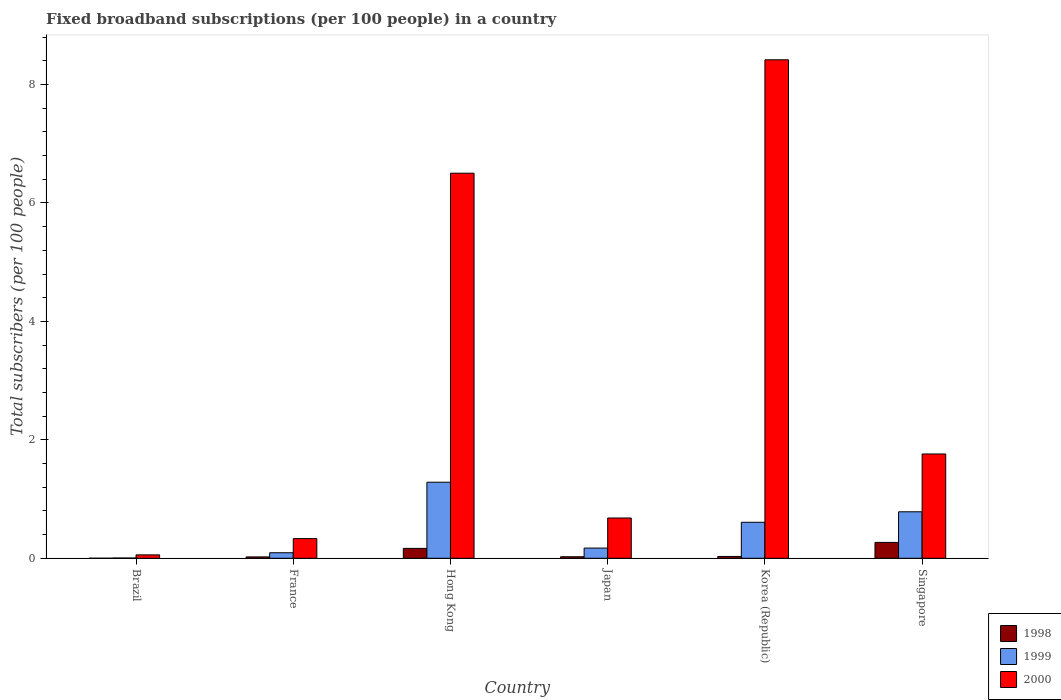Are the number of bars per tick equal to the number of legend labels?
Ensure brevity in your answer.  Yes. Are the number of bars on each tick of the X-axis equal?
Make the answer very short. Yes. What is the label of the 2nd group of bars from the left?
Keep it short and to the point. France. What is the number of broadband subscriptions in 1999 in Korea (Republic)?
Your answer should be very brief. 0.61. Across all countries, what is the maximum number of broadband subscriptions in 1999?
Keep it short and to the point. 1.28. Across all countries, what is the minimum number of broadband subscriptions in 1999?
Offer a terse response. 0. In which country was the number of broadband subscriptions in 1999 maximum?
Offer a very short reply. Hong Kong. In which country was the number of broadband subscriptions in 2000 minimum?
Provide a succinct answer. Brazil. What is the total number of broadband subscriptions in 1999 in the graph?
Your answer should be compact. 2.95. What is the difference between the number of broadband subscriptions in 2000 in Brazil and that in Korea (Republic)?
Keep it short and to the point. -8.36. What is the difference between the number of broadband subscriptions in 1999 in France and the number of broadband subscriptions in 2000 in Brazil?
Make the answer very short. 0.04. What is the average number of broadband subscriptions in 1999 per country?
Your answer should be very brief. 0.49. What is the difference between the number of broadband subscriptions of/in 1999 and number of broadband subscriptions of/in 2000 in France?
Your answer should be compact. -0.24. In how many countries, is the number of broadband subscriptions in 1999 greater than 3.6?
Give a very brief answer. 0. What is the ratio of the number of broadband subscriptions in 1998 in Hong Kong to that in Korea (Republic)?
Your answer should be very brief. 5.42. What is the difference between the highest and the second highest number of broadband subscriptions in 1998?
Give a very brief answer. 0.1. What is the difference between the highest and the lowest number of broadband subscriptions in 1998?
Your answer should be very brief. 0.27. Is the sum of the number of broadband subscriptions in 1999 in Hong Kong and Japan greater than the maximum number of broadband subscriptions in 1998 across all countries?
Keep it short and to the point. Yes. How many bars are there?
Ensure brevity in your answer.  18. Are all the bars in the graph horizontal?
Give a very brief answer. No. What is the difference between two consecutive major ticks on the Y-axis?
Keep it short and to the point. 2. Are the values on the major ticks of Y-axis written in scientific E-notation?
Keep it short and to the point. No. What is the title of the graph?
Provide a succinct answer. Fixed broadband subscriptions (per 100 people) in a country. Does "2003" appear as one of the legend labels in the graph?
Provide a succinct answer. No. What is the label or title of the X-axis?
Keep it short and to the point. Country. What is the label or title of the Y-axis?
Ensure brevity in your answer.  Total subscribers (per 100 people). What is the Total subscribers (per 100 people) of 1998 in Brazil?
Your answer should be compact. 0. What is the Total subscribers (per 100 people) of 1999 in Brazil?
Your answer should be very brief. 0. What is the Total subscribers (per 100 people) in 2000 in Brazil?
Ensure brevity in your answer.  0.06. What is the Total subscribers (per 100 people) in 1998 in France?
Offer a terse response. 0.02. What is the Total subscribers (per 100 people) of 1999 in France?
Offer a very short reply. 0.09. What is the Total subscribers (per 100 people) of 2000 in France?
Your response must be concise. 0.33. What is the Total subscribers (per 100 people) of 1998 in Hong Kong?
Your answer should be compact. 0.17. What is the Total subscribers (per 100 people) in 1999 in Hong Kong?
Make the answer very short. 1.28. What is the Total subscribers (per 100 people) of 2000 in Hong Kong?
Your response must be concise. 6.5. What is the Total subscribers (per 100 people) of 1998 in Japan?
Your answer should be very brief. 0.03. What is the Total subscribers (per 100 people) of 1999 in Japan?
Your response must be concise. 0.17. What is the Total subscribers (per 100 people) of 2000 in Japan?
Make the answer very short. 0.68. What is the Total subscribers (per 100 people) of 1998 in Korea (Republic)?
Your answer should be compact. 0.03. What is the Total subscribers (per 100 people) of 1999 in Korea (Republic)?
Ensure brevity in your answer.  0.61. What is the Total subscribers (per 100 people) of 2000 in Korea (Republic)?
Your response must be concise. 8.42. What is the Total subscribers (per 100 people) of 1998 in Singapore?
Give a very brief answer. 0.27. What is the Total subscribers (per 100 people) in 1999 in Singapore?
Your answer should be very brief. 0.78. What is the Total subscribers (per 100 people) of 2000 in Singapore?
Provide a succinct answer. 1.76. Across all countries, what is the maximum Total subscribers (per 100 people) in 1998?
Provide a short and direct response. 0.27. Across all countries, what is the maximum Total subscribers (per 100 people) in 1999?
Your response must be concise. 1.28. Across all countries, what is the maximum Total subscribers (per 100 people) of 2000?
Offer a very short reply. 8.42. Across all countries, what is the minimum Total subscribers (per 100 people) of 1998?
Your answer should be compact. 0. Across all countries, what is the minimum Total subscribers (per 100 people) in 1999?
Ensure brevity in your answer.  0. Across all countries, what is the minimum Total subscribers (per 100 people) of 2000?
Provide a succinct answer. 0.06. What is the total Total subscribers (per 100 people) in 1998 in the graph?
Offer a terse response. 0.51. What is the total Total subscribers (per 100 people) in 1999 in the graph?
Provide a succinct answer. 2.95. What is the total Total subscribers (per 100 people) of 2000 in the graph?
Give a very brief answer. 17.75. What is the difference between the Total subscribers (per 100 people) in 1998 in Brazil and that in France?
Your answer should be compact. -0.02. What is the difference between the Total subscribers (per 100 people) in 1999 in Brazil and that in France?
Make the answer very short. -0.09. What is the difference between the Total subscribers (per 100 people) in 2000 in Brazil and that in France?
Offer a very short reply. -0.27. What is the difference between the Total subscribers (per 100 people) in 1998 in Brazil and that in Hong Kong?
Provide a succinct answer. -0.17. What is the difference between the Total subscribers (per 100 people) of 1999 in Brazil and that in Hong Kong?
Offer a terse response. -1.28. What is the difference between the Total subscribers (per 100 people) of 2000 in Brazil and that in Hong Kong?
Keep it short and to the point. -6.45. What is the difference between the Total subscribers (per 100 people) of 1998 in Brazil and that in Japan?
Provide a succinct answer. -0.03. What is the difference between the Total subscribers (per 100 people) of 1999 in Brazil and that in Japan?
Keep it short and to the point. -0.17. What is the difference between the Total subscribers (per 100 people) of 2000 in Brazil and that in Japan?
Give a very brief answer. -0.62. What is the difference between the Total subscribers (per 100 people) of 1998 in Brazil and that in Korea (Republic)?
Keep it short and to the point. -0.03. What is the difference between the Total subscribers (per 100 people) in 1999 in Brazil and that in Korea (Republic)?
Make the answer very short. -0.6. What is the difference between the Total subscribers (per 100 people) in 2000 in Brazil and that in Korea (Republic)?
Ensure brevity in your answer.  -8.36. What is the difference between the Total subscribers (per 100 people) of 1998 in Brazil and that in Singapore?
Give a very brief answer. -0.27. What is the difference between the Total subscribers (per 100 people) of 1999 in Brazil and that in Singapore?
Your response must be concise. -0.78. What is the difference between the Total subscribers (per 100 people) of 2000 in Brazil and that in Singapore?
Make the answer very short. -1.7. What is the difference between the Total subscribers (per 100 people) in 1998 in France and that in Hong Kong?
Offer a very short reply. -0.14. What is the difference between the Total subscribers (per 100 people) in 1999 in France and that in Hong Kong?
Provide a succinct answer. -1.19. What is the difference between the Total subscribers (per 100 people) in 2000 in France and that in Hong Kong?
Keep it short and to the point. -6.17. What is the difference between the Total subscribers (per 100 people) in 1998 in France and that in Japan?
Make the answer very short. -0. What is the difference between the Total subscribers (per 100 people) in 1999 in France and that in Japan?
Your answer should be compact. -0.08. What is the difference between the Total subscribers (per 100 people) of 2000 in France and that in Japan?
Give a very brief answer. -0.35. What is the difference between the Total subscribers (per 100 people) of 1998 in France and that in Korea (Republic)?
Your response must be concise. -0.01. What is the difference between the Total subscribers (per 100 people) in 1999 in France and that in Korea (Republic)?
Offer a terse response. -0.51. What is the difference between the Total subscribers (per 100 people) in 2000 in France and that in Korea (Republic)?
Your response must be concise. -8.09. What is the difference between the Total subscribers (per 100 people) in 1998 in France and that in Singapore?
Provide a short and direct response. -0.24. What is the difference between the Total subscribers (per 100 people) in 1999 in France and that in Singapore?
Your answer should be very brief. -0.69. What is the difference between the Total subscribers (per 100 people) of 2000 in France and that in Singapore?
Keep it short and to the point. -1.43. What is the difference between the Total subscribers (per 100 people) in 1998 in Hong Kong and that in Japan?
Offer a terse response. 0.14. What is the difference between the Total subscribers (per 100 people) of 1999 in Hong Kong and that in Japan?
Provide a succinct answer. 1.11. What is the difference between the Total subscribers (per 100 people) in 2000 in Hong Kong and that in Japan?
Your response must be concise. 5.82. What is the difference between the Total subscribers (per 100 people) in 1998 in Hong Kong and that in Korea (Republic)?
Your answer should be very brief. 0.14. What is the difference between the Total subscribers (per 100 people) of 1999 in Hong Kong and that in Korea (Republic)?
Your answer should be very brief. 0.68. What is the difference between the Total subscribers (per 100 people) of 2000 in Hong Kong and that in Korea (Republic)?
Offer a terse response. -1.91. What is the difference between the Total subscribers (per 100 people) in 1998 in Hong Kong and that in Singapore?
Provide a short and direct response. -0.1. What is the difference between the Total subscribers (per 100 people) in 1999 in Hong Kong and that in Singapore?
Offer a very short reply. 0.5. What is the difference between the Total subscribers (per 100 people) of 2000 in Hong Kong and that in Singapore?
Provide a succinct answer. 4.74. What is the difference between the Total subscribers (per 100 people) in 1998 in Japan and that in Korea (Republic)?
Your response must be concise. -0.01. What is the difference between the Total subscribers (per 100 people) of 1999 in Japan and that in Korea (Republic)?
Make the answer very short. -0.44. What is the difference between the Total subscribers (per 100 people) of 2000 in Japan and that in Korea (Republic)?
Ensure brevity in your answer.  -7.74. What is the difference between the Total subscribers (per 100 people) of 1998 in Japan and that in Singapore?
Your response must be concise. -0.24. What is the difference between the Total subscribers (per 100 people) of 1999 in Japan and that in Singapore?
Provide a succinct answer. -0.61. What is the difference between the Total subscribers (per 100 people) of 2000 in Japan and that in Singapore?
Provide a succinct answer. -1.08. What is the difference between the Total subscribers (per 100 people) in 1998 in Korea (Republic) and that in Singapore?
Your answer should be very brief. -0.24. What is the difference between the Total subscribers (per 100 people) in 1999 in Korea (Republic) and that in Singapore?
Give a very brief answer. -0.18. What is the difference between the Total subscribers (per 100 people) in 2000 in Korea (Republic) and that in Singapore?
Your response must be concise. 6.66. What is the difference between the Total subscribers (per 100 people) of 1998 in Brazil and the Total subscribers (per 100 people) of 1999 in France?
Offer a very short reply. -0.09. What is the difference between the Total subscribers (per 100 people) in 1998 in Brazil and the Total subscribers (per 100 people) in 2000 in France?
Offer a terse response. -0.33. What is the difference between the Total subscribers (per 100 people) in 1999 in Brazil and the Total subscribers (per 100 people) in 2000 in France?
Your answer should be very brief. -0.33. What is the difference between the Total subscribers (per 100 people) in 1998 in Brazil and the Total subscribers (per 100 people) in 1999 in Hong Kong?
Offer a very short reply. -1.28. What is the difference between the Total subscribers (per 100 people) of 1998 in Brazil and the Total subscribers (per 100 people) of 2000 in Hong Kong?
Provide a succinct answer. -6.5. What is the difference between the Total subscribers (per 100 people) in 1999 in Brazil and the Total subscribers (per 100 people) in 2000 in Hong Kong?
Your answer should be compact. -6.5. What is the difference between the Total subscribers (per 100 people) in 1998 in Brazil and the Total subscribers (per 100 people) in 1999 in Japan?
Provide a short and direct response. -0.17. What is the difference between the Total subscribers (per 100 people) in 1998 in Brazil and the Total subscribers (per 100 people) in 2000 in Japan?
Give a very brief answer. -0.68. What is the difference between the Total subscribers (per 100 people) of 1999 in Brazil and the Total subscribers (per 100 people) of 2000 in Japan?
Make the answer very short. -0.68. What is the difference between the Total subscribers (per 100 people) of 1998 in Brazil and the Total subscribers (per 100 people) of 1999 in Korea (Republic)?
Ensure brevity in your answer.  -0.61. What is the difference between the Total subscribers (per 100 people) of 1998 in Brazil and the Total subscribers (per 100 people) of 2000 in Korea (Republic)?
Offer a terse response. -8.42. What is the difference between the Total subscribers (per 100 people) of 1999 in Brazil and the Total subscribers (per 100 people) of 2000 in Korea (Republic)?
Make the answer very short. -8.41. What is the difference between the Total subscribers (per 100 people) in 1998 in Brazil and the Total subscribers (per 100 people) in 1999 in Singapore?
Ensure brevity in your answer.  -0.78. What is the difference between the Total subscribers (per 100 people) of 1998 in Brazil and the Total subscribers (per 100 people) of 2000 in Singapore?
Ensure brevity in your answer.  -1.76. What is the difference between the Total subscribers (per 100 people) in 1999 in Brazil and the Total subscribers (per 100 people) in 2000 in Singapore?
Your answer should be very brief. -1.76. What is the difference between the Total subscribers (per 100 people) in 1998 in France and the Total subscribers (per 100 people) in 1999 in Hong Kong?
Make the answer very short. -1.26. What is the difference between the Total subscribers (per 100 people) of 1998 in France and the Total subscribers (per 100 people) of 2000 in Hong Kong?
Your response must be concise. -6.48. What is the difference between the Total subscribers (per 100 people) of 1999 in France and the Total subscribers (per 100 people) of 2000 in Hong Kong?
Offer a terse response. -6.41. What is the difference between the Total subscribers (per 100 people) of 1998 in France and the Total subscribers (per 100 people) of 1999 in Japan?
Your response must be concise. -0.15. What is the difference between the Total subscribers (per 100 people) in 1998 in France and the Total subscribers (per 100 people) in 2000 in Japan?
Provide a succinct answer. -0.66. What is the difference between the Total subscribers (per 100 people) in 1999 in France and the Total subscribers (per 100 people) in 2000 in Japan?
Ensure brevity in your answer.  -0.59. What is the difference between the Total subscribers (per 100 people) of 1998 in France and the Total subscribers (per 100 people) of 1999 in Korea (Republic)?
Your response must be concise. -0.58. What is the difference between the Total subscribers (per 100 people) in 1998 in France and the Total subscribers (per 100 people) in 2000 in Korea (Republic)?
Offer a terse response. -8.39. What is the difference between the Total subscribers (per 100 people) of 1999 in France and the Total subscribers (per 100 people) of 2000 in Korea (Republic)?
Provide a short and direct response. -8.32. What is the difference between the Total subscribers (per 100 people) in 1998 in France and the Total subscribers (per 100 people) in 1999 in Singapore?
Offer a terse response. -0.76. What is the difference between the Total subscribers (per 100 people) of 1998 in France and the Total subscribers (per 100 people) of 2000 in Singapore?
Provide a succinct answer. -1.74. What is the difference between the Total subscribers (per 100 people) in 1999 in France and the Total subscribers (per 100 people) in 2000 in Singapore?
Give a very brief answer. -1.67. What is the difference between the Total subscribers (per 100 people) in 1998 in Hong Kong and the Total subscribers (per 100 people) in 1999 in Japan?
Give a very brief answer. -0.01. What is the difference between the Total subscribers (per 100 people) of 1998 in Hong Kong and the Total subscribers (per 100 people) of 2000 in Japan?
Your response must be concise. -0.51. What is the difference between the Total subscribers (per 100 people) of 1999 in Hong Kong and the Total subscribers (per 100 people) of 2000 in Japan?
Offer a very short reply. 0.6. What is the difference between the Total subscribers (per 100 people) of 1998 in Hong Kong and the Total subscribers (per 100 people) of 1999 in Korea (Republic)?
Offer a very short reply. -0.44. What is the difference between the Total subscribers (per 100 people) in 1998 in Hong Kong and the Total subscribers (per 100 people) in 2000 in Korea (Republic)?
Give a very brief answer. -8.25. What is the difference between the Total subscribers (per 100 people) in 1999 in Hong Kong and the Total subscribers (per 100 people) in 2000 in Korea (Republic)?
Provide a short and direct response. -7.13. What is the difference between the Total subscribers (per 100 people) in 1998 in Hong Kong and the Total subscribers (per 100 people) in 1999 in Singapore?
Keep it short and to the point. -0.62. What is the difference between the Total subscribers (per 100 people) in 1998 in Hong Kong and the Total subscribers (per 100 people) in 2000 in Singapore?
Give a very brief answer. -1.59. What is the difference between the Total subscribers (per 100 people) of 1999 in Hong Kong and the Total subscribers (per 100 people) of 2000 in Singapore?
Provide a succinct answer. -0.48. What is the difference between the Total subscribers (per 100 people) of 1998 in Japan and the Total subscribers (per 100 people) of 1999 in Korea (Republic)?
Ensure brevity in your answer.  -0.58. What is the difference between the Total subscribers (per 100 people) of 1998 in Japan and the Total subscribers (per 100 people) of 2000 in Korea (Republic)?
Ensure brevity in your answer.  -8.39. What is the difference between the Total subscribers (per 100 people) in 1999 in Japan and the Total subscribers (per 100 people) in 2000 in Korea (Republic)?
Your response must be concise. -8.25. What is the difference between the Total subscribers (per 100 people) in 1998 in Japan and the Total subscribers (per 100 people) in 1999 in Singapore?
Provide a short and direct response. -0.76. What is the difference between the Total subscribers (per 100 people) of 1998 in Japan and the Total subscribers (per 100 people) of 2000 in Singapore?
Make the answer very short. -1.74. What is the difference between the Total subscribers (per 100 people) in 1999 in Japan and the Total subscribers (per 100 people) in 2000 in Singapore?
Your response must be concise. -1.59. What is the difference between the Total subscribers (per 100 people) of 1998 in Korea (Republic) and the Total subscribers (per 100 people) of 1999 in Singapore?
Offer a terse response. -0.75. What is the difference between the Total subscribers (per 100 people) in 1998 in Korea (Republic) and the Total subscribers (per 100 people) in 2000 in Singapore?
Provide a succinct answer. -1.73. What is the difference between the Total subscribers (per 100 people) of 1999 in Korea (Republic) and the Total subscribers (per 100 people) of 2000 in Singapore?
Your answer should be very brief. -1.15. What is the average Total subscribers (per 100 people) of 1998 per country?
Ensure brevity in your answer.  0.09. What is the average Total subscribers (per 100 people) in 1999 per country?
Ensure brevity in your answer.  0.49. What is the average Total subscribers (per 100 people) of 2000 per country?
Offer a terse response. 2.96. What is the difference between the Total subscribers (per 100 people) in 1998 and Total subscribers (per 100 people) in 1999 in Brazil?
Your answer should be very brief. -0. What is the difference between the Total subscribers (per 100 people) of 1998 and Total subscribers (per 100 people) of 2000 in Brazil?
Provide a succinct answer. -0.06. What is the difference between the Total subscribers (per 100 people) of 1999 and Total subscribers (per 100 people) of 2000 in Brazil?
Offer a terse response. -0.05. What is the difference between the Total subscribers (per 100 people) in 1998 and Total subscribers (per 100 people) in 1999 in France?
Offer a very short reply. -0.07. What is the difference between the Total subscribers (per 100 people) of 1998 and Total subscribers (per 100 people) of 2000 in France?
Your answer should be compact. -0.31. What is the difference between the Total subscribers (per 100 people) in 1999 and Total subscribers (per 100 people) in 2000 in France?
Offer a very short reply. -0.24. What is the difference between the Total subscribers (per 100 people) in 1998 and Total subscribers (per 100 people) in 1999 in Hong Kong?
Provide a short and direct response. -1.12. What is the difference between the Total subscribers (per 100 people) in 1998 and Total subscribers (per 100 people) in 2000 in Hong Kong?
Offer a terse response. -6.34. What is the difference between the Total subscribers (per 100 people) in 1999 and Total subscribers (per 100 people) in 2000 in Hong Kong?
Ensure brevity in your answer.  -5.22. What is the difference between the Total subscribers (per 100 people) of 1998 and Total subscribers (per 100 people) of 1999 in Japan?
Ensure brevity in your answer.  -0.15. What is the difference between the Total subscribers (per 100 people) of 1998 and Total subscribers (per 100 people) of 2000 in Japan?
Offer a very short reply. -0.65. What is the difference between the Total subscribers (per 100 people) in 1999 and Total subscribers (per 100 people) in 2000 in Japan?
Ensure brevity in your answer.  -0.51. What is the difference between the Total subscribers (per 100 people) of 1998 and Total subscribers (per 100 people) of 1999 in Korea (Republic)?
Ensure brevity in your answer.  -0.58. What is the difference between the Total subscribers (per 100 people) in 1998 and Total subscribers (per 100 people) in 2000 in Korea (Republic)?
Provide a short and direct response. -8.39. What is the difference between the Total subscribers (per 100 people) of 1999 and Total subscribers (per 100 people) of 2000 in Korea (Republic)?
Keep it short and to the point. -7.81. What is the difference between the Total subscribers (per 100 people) of 1998 and Total subscribers (per 100 people) of 1999 in Singapore?
Provide a succinct answer. -0.52. What is the difference between the Total subscribers (per 100 people) in 1998 and Total subscribers (per 100 people) in 2000 in Singapore?
Give a very brief answer. -1.49. What is the difference between the Total subscribers (per 100 people) in 1999 and Total subscribers (per 100 people) in 2000 in Singapore?
Your response must be concise. -0.98. What is the ratio of the Total subscribers (per 100 people) of 1998 in Brazil to that in France?
Provide a succinct answer. 0.03. What is the ratio of the Total subscribers (per 100 people) of 1999 in Brazil to that in France?
Provide a short and direct response. 0.04. What is the ratio of the Total subscribers (per 100 people) in 2000 in Brazil to that in France?
Offer a very short reply. 0.17. What is the ratio of the Total subscribers (per 100 people) in 1998 in Brazil to that in Hong Kong?
Offer a very short reply. 0. What is the ratio of the Total subscribers (per 100 people) in 1999 in Brazil to that in Hong Kong?
Your response must be concise. 0. What is the ratio of the Total subscribers (per 100 people) of 2000 in Brazil to that in Hong Kong?
Offer a terse response. 0.01. What is the ratio of the Total subscribers (per 100 people) of 1998 in Brazil to that in Japan?
Offer a very short reply. 0.02. What is the ratio of the Total subscribers (per 100 people) in 1999 in Brazil to that in Japan?
Keep it short and to the point. 0.02. What is the ratio of the Total subscribers (per 100 people) of 2000 in Brazil to that in Japan?
Your response must be concise. 0.08. What is the ratio of the Total subscribers (per 100 people) of 1998 in Brazil to that in Korea (Republic)?
Keep it short and to the point. 0.02. What is the ratio of the Total subscribers (per 100 people) in 1999 in Brazil to that in Korea (Republic)?
Your answer should be compact. 0.01. What is the ratio of the Total subscribers (per 100 people) of 2000 in Brazil to that in Korea (Republic)?
Ensure brevity in your answer.  0.01. What is the ratio of the Total subscribers (per 100 people) of 1998 in Brazil to that in Singapore?
Offer a very short reply. 0. What is the ratio of the Total subscribers (per 100 people) of 1999 in Brazil to that in Singapore?
Make the answer very short. 0.01. What is the ratio of the Total subscribers (per 100 people) of 2000 in Brazil to that in Singapore?
Offer a terse response. 0.03. What is the ratio of the Total subscribers (per 100 people) of 1998 in France to that in Hong Kong?
Offer a terse response. 0.14. What is the ratio of the Total subscribers (per 100 people) in 1999 in France to that in Hong Kong?
Your answer should be compact. 0.07. What is the ratio of the Total subscribers (per 100 people) in 2000 in France to that in Hong Kong?
Your answer should be compact. 0.05. What is the ratio of the Total subscribers (per 100 people) of 1998 in France to that in Japan?
Keep it short and to the point. 0.9. What is the ratio of the Total subscribers (per 100 people) in 1999 in France to that in Japan?
Offer a terse response. 0.54. What is the ratio of the Total subscribers (per 100 people) in 2000 in France to that in Japan?
Ensure brevity in your answer.  0.49. What is the ratio of the Total subscribers (per 100 people) of 1998 in France to that in Korea (Republic)?
Make the answer very short. 0.75. What is the ratio of the Total subscribers (per 100 people) of 1999 in France to that in Korea (Republic)?
Make the answer very short. 0.15. What is the ratio of the Total subscribers (per 100 people) of 2000 in France to that in Korea (Republic)?
Your answer should be compact. 0.04. What is the ratio of the Total subscribers (per 100 people) of 1998 in France to that in Singapore?
Your answer should be very brief. 0.09. What is the ratio of the Total subscribers (per 100 people) in 1999 in France to that in Singapore?
Keep it short and to the point. 0.12. What is the ratio of the Total subscribers (per 100 people) in 2000 in France to that in Singapore?
Make the answer very short. 0.19. What is the ratio of the Total subscribers (per 100 people) in 1998 in Hong Kong to that in Japan?
Provide a short and direct response. 6.53. What is the ratio of the Total subscribers (per 100 people) in 1999 in Hong Kong to that in Japan?
Keep it short and to the point. 7.46. What is the ratio of the Total subscribers (per 100 people) of 2000 in Hong Kong to that in Japan?
Your answer should be very brief. 9.56. What is the ratio of the Total subscribers (per 100 people) in 1998 in Hong Kong to that in Korea (Republic)?
Offer a very short reply. 5.42. What is the ratio of the Total subscribers (per 100 people) in 1999 in Hong Kong to that in Korea (Republic)?
Make the answer very short. 2.11. What is the ratio of the Total subscribers (per 100 people) in 2000 in Hong Kong to that in Korea (Republic)?
Ensure brevity in your answer.  0.77. What is the ratio of the Total subscribers (per 100 people) of 1998 in Hong Kong to that in Singapore?
Give a very brief answer. 0.62. What is the ratio of the Total subscribers (per 100 people) in 1999 in Hong Kong to that in Singapore?
Provide a short and direct response. 1.64. What is the ratio of the Total subscribers (per 100 people) in 2000 in Hong Kong to that in Singapore?
Your answer should be compact. 3.69. What is the ratio of the Total subscribers (per 100 people) of 1998 in Japan to that in Korea (Republic)?
Keep it short and to the point. 0.83. What is the ratio of the Total subscribers (per 100 people) in 1999 in Japan to that in Korea (Republic)?
Ensure brevity in your answer.  0.28. What is the ratio of the Total subscribers (per 100 people) of 2000 in Japan to that in Korea (Republic)?
Your answer should be compact. 0.08. What is the ratio of the Total subscribers (per 100 people) in 1998 in Japan to that in Singapore?
Offer a terse response. 0.1. What is the ratio of the Total subscribers (per 100 people) in 1999 in Japan to that in Singapore?
Your response must be concise. 0.22. What is the ratio of the Total subscribers (per 100 people) in 2000 in Japan to that in Singapore?
Provide a succinct answer. 0.39. What is the ratio of the Total subscribers (per 100 people) in 1998 in Korea (Republic) to that in Singapore?
Give a very brief answer. 0.12. What is the ratio of the Total subscribers (per 100 people) in 1999 in Korea (Republic) to that in Singapore?
Offer a terse response. 0.77. What is the ratio of the Total subscribers (per 100 people) in 2000 in Korea (Republic) to that in Singapore?
Make the answer very short. 4.78. What is the difference between the highest and the second highest Total subscribers (per 100 people) of 1998?
Provide a short and direct response. 0.1. What is the difference between the highest and the second highest Total subscribers (per 100 people) in 1999?
Offer a very short reply. 0.5. What is the difference between the highest and the second highest Total subscribers (per 100 people) of 2000?
Your answer should be compact. 1.91. What is the difference between the highest and the lowest Total subscribers (per 100 people) in 1998?
Provide a succinct answer. 0.27. What is the difference between the highest and the lowest Total subscribers (per 100 people) of 1999?
Provide a short and direct response. 1.28. What is the difference between the highest and the lowest Total subscribers (per 100 people) in 2000?
Provide a short and direct response. 8.36. 